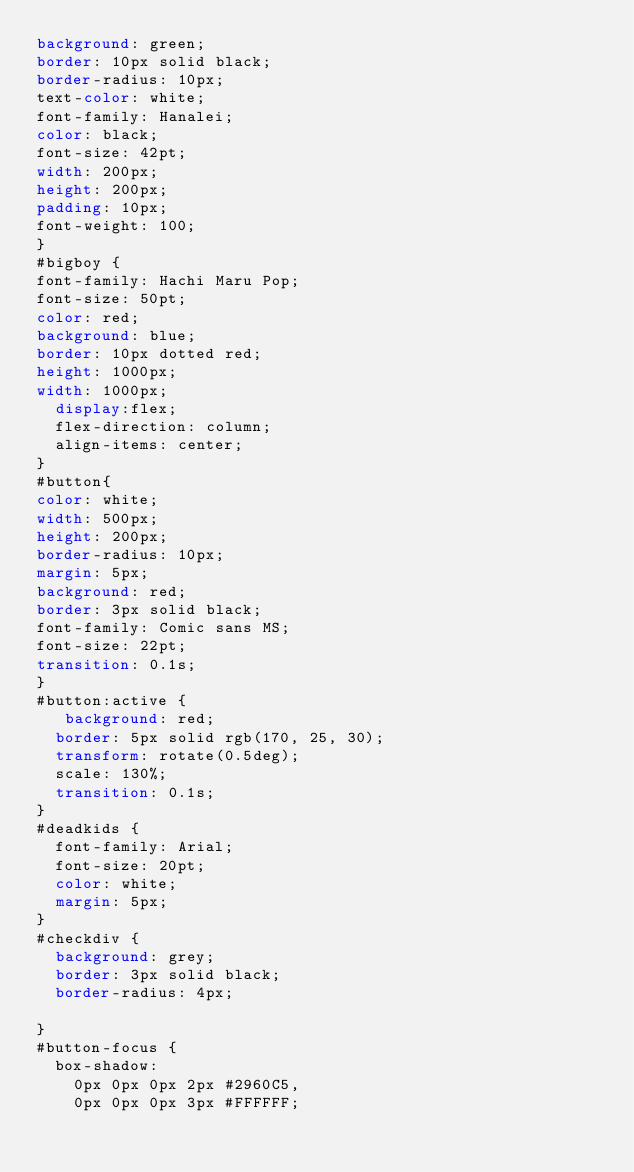<code> <loc_0><loc_0><loc_500><loc_500><_CSS_>background: green;
border: 10px solid black;
border-radius: 10px;
text-color: white;
font-family: Hanalei;
color: black;
font-size: 42pt;
width: 200px;
height: 200px;
padding: 10px;
font-weight: 100;
}
#bigboy {
font-family: Hachi Maru Pop;
font-size: 50pt;
color: red;
background: blue;
border: 10px dotted red;
height: 1000px;
width: 1000px;
  display:flex;
  flex-direction: column;
  align-items: center;
}
#button{
color: white;
width: 500px;
height: 200px;
border-radius: 10px;
margin: 5px;
background: red;
border: 3px solid black;
font-family: Comic sans MS;
font-size: 22pt;
transition: 0.1s;
}
#button:active {
   background: red;
  border: 5px solid rgb(170, 25, 30);
  transform: rotate(0.5deg);
  scale: 130%;
  transition: 0.1s;
}
#deadkids {
  font-family: Arial;
  font-size: 20pt;
  color: white;
  margin: 5px;
}
#checkdiv {
  background: grey;
  border: 3px solid black;
  border-radius: 4px;
  
}
#button-focus {
  box-shadow: 
    0px 0px 0px 2px #2960C5,
    0px 0px 0px 3px #FFFFFF;</code> 